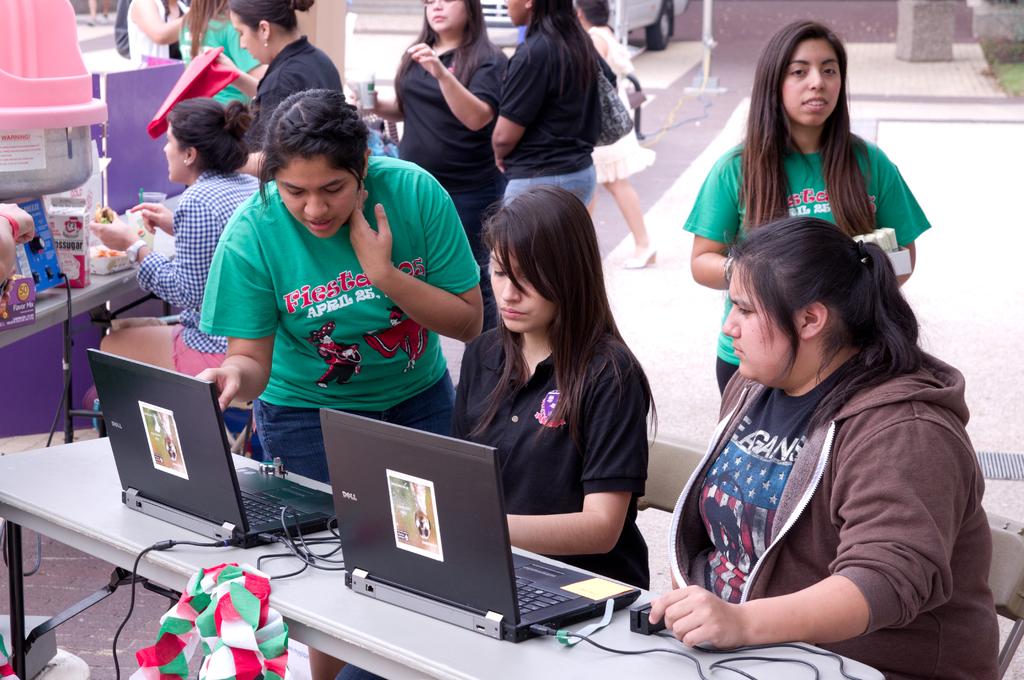What month is shown on the green shirt?
Make the answer very short. April. 